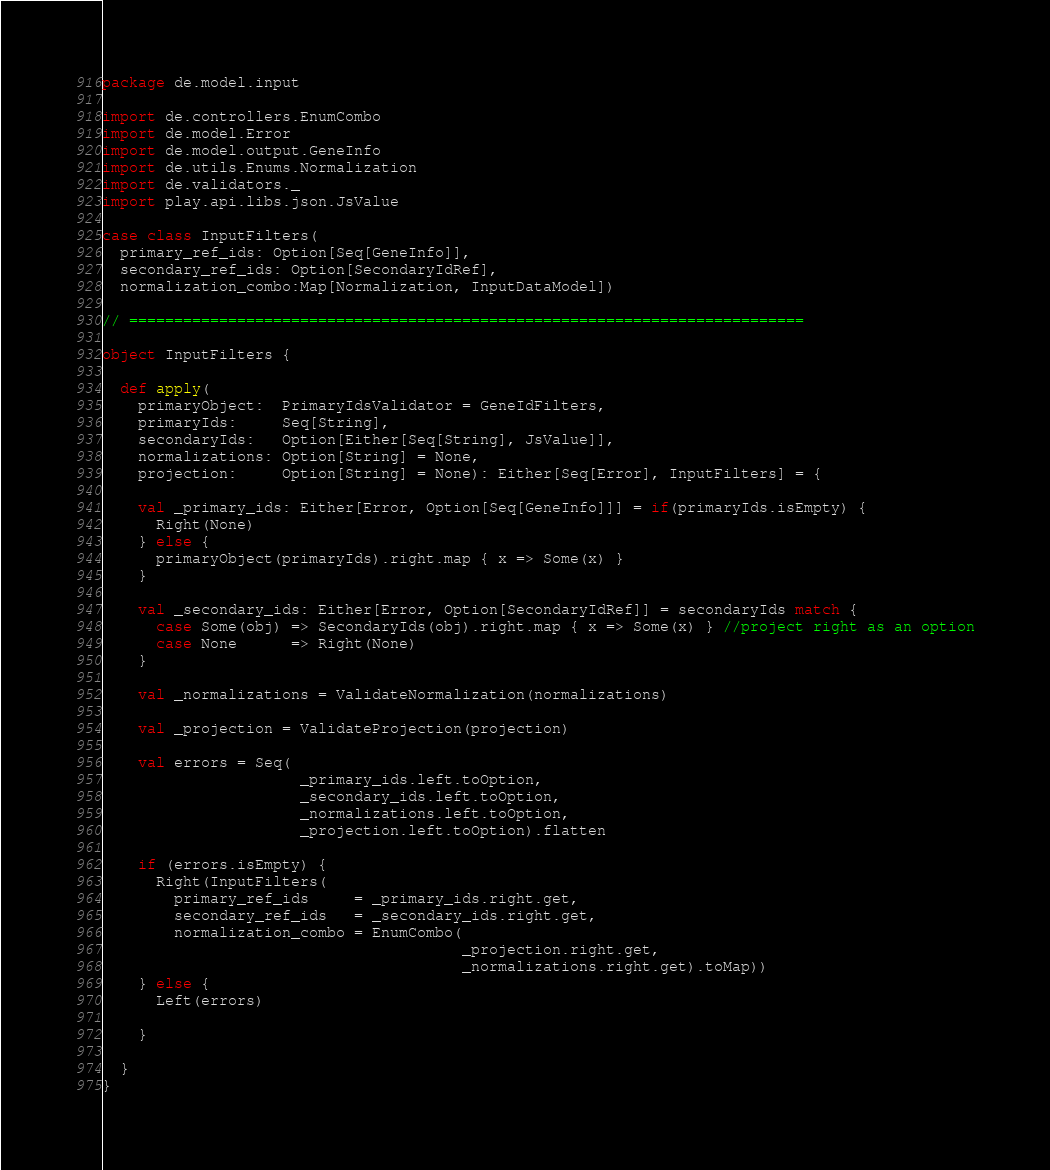<code> <loc_0><loc_0><loc_500><loc_500><_Scala_>package de.model.input

import de.controllers.EnumCombo
import de.model.Error
import de.model.output.GeneInfo
import de.utils.Enums.Normalization
import de.validators._
import play.api.libs.json.JsValue

case class InputFilters(
  primary_ref_ids: Option[Seq[GeneInfo]],
  secondary_ref_ids: Option[SecondaryIdRef],
  normalization_combo:Map[Normalization, InputDataModel])

// ===========================================================================

object InputFilters {

  def apply(
    primaryObject:  PrimaryIdsValidator = GeneIdFilters,
    primaryIds:     Seq[String],
    secondaryIds:   Option[Either[Seq[String], JsValue]],
    normalizations: Option[String] = None,
    projection:     Option[String] = None): Either[Seq[Error], InputFilters] = {

    val _primary_ids: Either[Error, Option[Seq[GeneInfo]]] = if(primaryIds.isEmpty) {
      Right(None)
    } else {
      primaryObject(primaryIds).right.map { x => Some(x) }
    }

    val _secondary_ids: Either[Error, Option[SecondaryIdRef]] = secondaryIds match {
      case Some(obj) => SecondaryIds(obj).right.map { x => Some(x) } //project right as an option
      case None      => Right(None)
    }

    val _normalizations = ValidateNormalization(normalizations)

    val _projection = ValidateProjection(projection)

    val errors = Seq(
                      _primary_ids.left.toOption,
                      _secondary_ids.left.toOption,
                      _normalizations.left.toOption,
                      _projection.left.toOption).flatten

    if (errors.isEmpty) {
      Right(InputFilters(
        primary_ref_ids     = _primary_ids.right.get,
        secondary_ref_ids   = _secondary_ids.right.get,
        normalization_combo = EnumCombo(
                                        _projection.right.get,
                                        _normalizations.right.get).toMap))
    } else {
      Left(errors)

    }

  }
}
</code> 